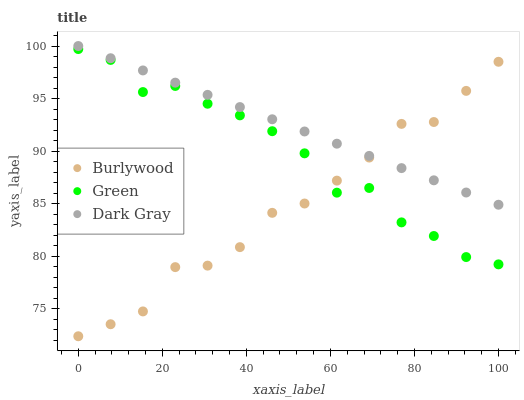Does Burlywood have the minimum area under the curve?
Answer yes or no. Yes. Does Dark Gray have the maximum area under the curve?
Answer yes or no. Yes. Does Green have the minimum area under the curve?
Answer yes or no. No. Does Green have the maximum area under the curve?
Answer yes or no. No. Is Dark Gray the smoothest?
Answer yes or no. Yes. Is Green the roughest?
Answer yes or no. Yes. Is Green the smoothest?
Answer yes or no. No. Is Dark Gray the roughest?
Answer yes or no. No. Does Burlywood have the lowest value?
Answer yes or no. Yes. Does Green have the lowest value?
Answer yes or no. No. Does Dark Gray have the highest value?
Answer yes or no. Yes. Does Green have the highest value?
Answer yes or no. No. Is Green less than Dark Gray?
Answer yes or no. Yes. Is Dark Gray greater than Green?
Answer yes or no. Yes. Does Burlywood intersect Dark Gray?
Answer yes or no. Yes. Is Burlywood less than Dark Gray?
Answer yes or no. No. Is Burlywood greater than Dark Gray?
Answer yes or no. No. Does Green intersect Dark Gray?
Answer yes or no. No. 